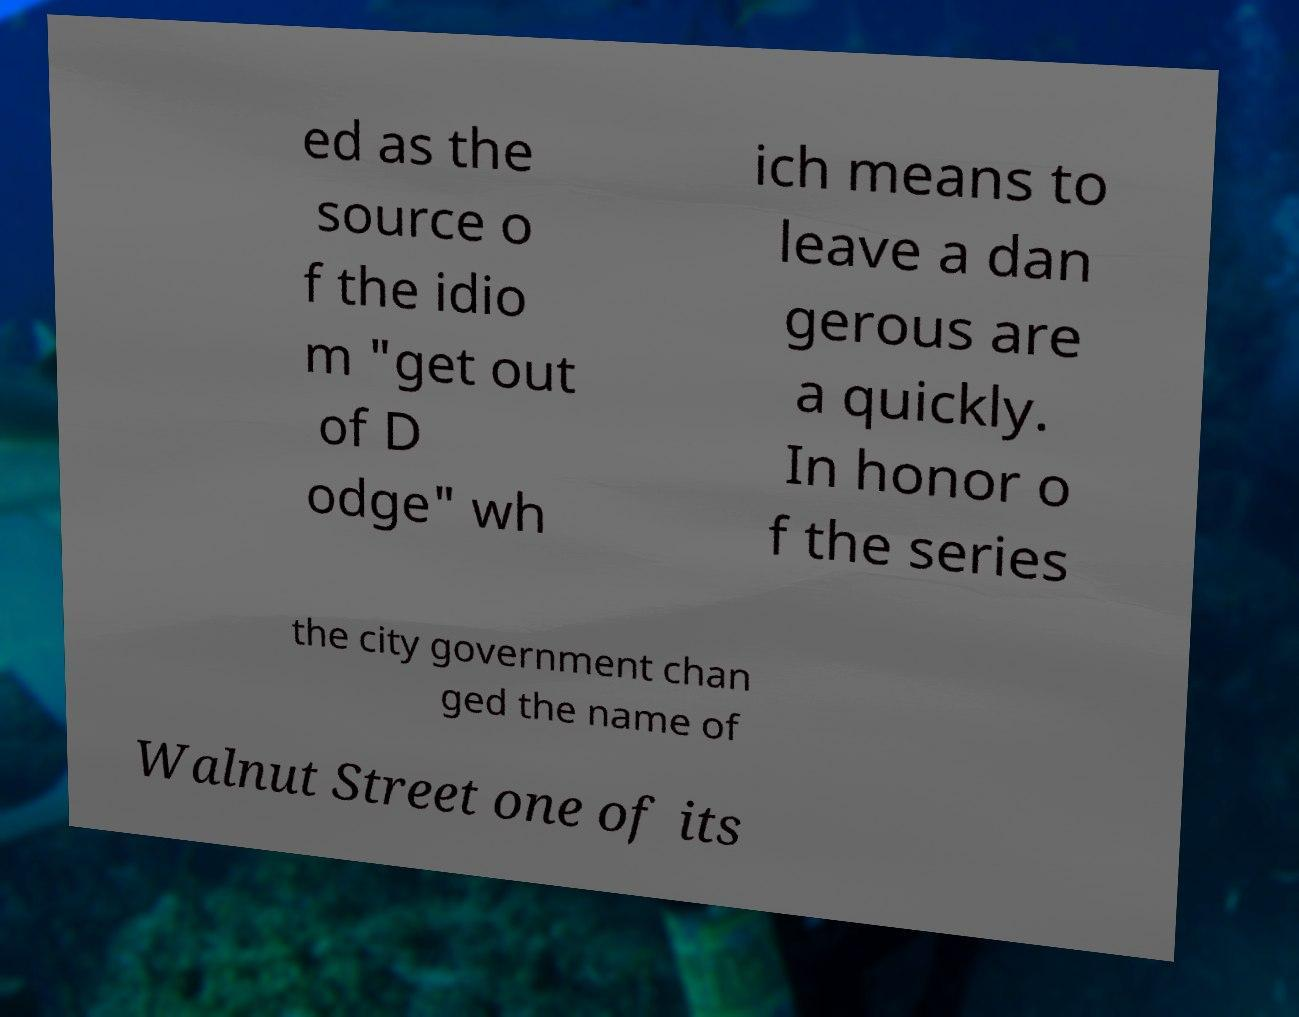Could you extract and type out the text from this image? ed as the source o f the idio m "get out of D odge" wh ich means to leave a dan gerous are a quickly. In honor o f the series the city government chan ged the name of Walnut Street one of its 